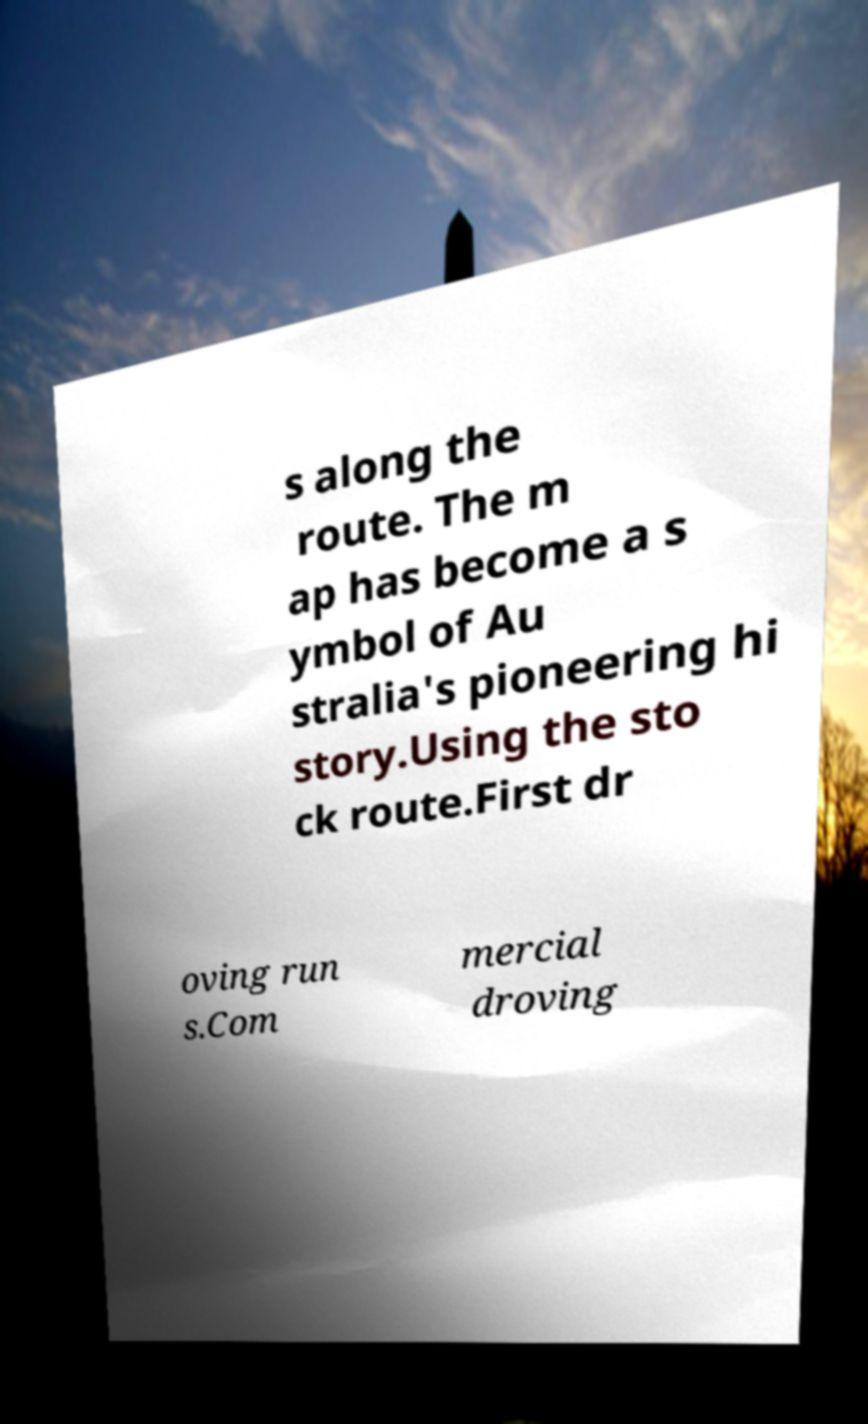For documentation purposes, I need the text within this image transcribed. Could you provide that? s along the route. The m ap has become a s ymbol of Au stralia's pioneering hi story.Using the sto ck route.First dr oving run s.Com mercial droving 